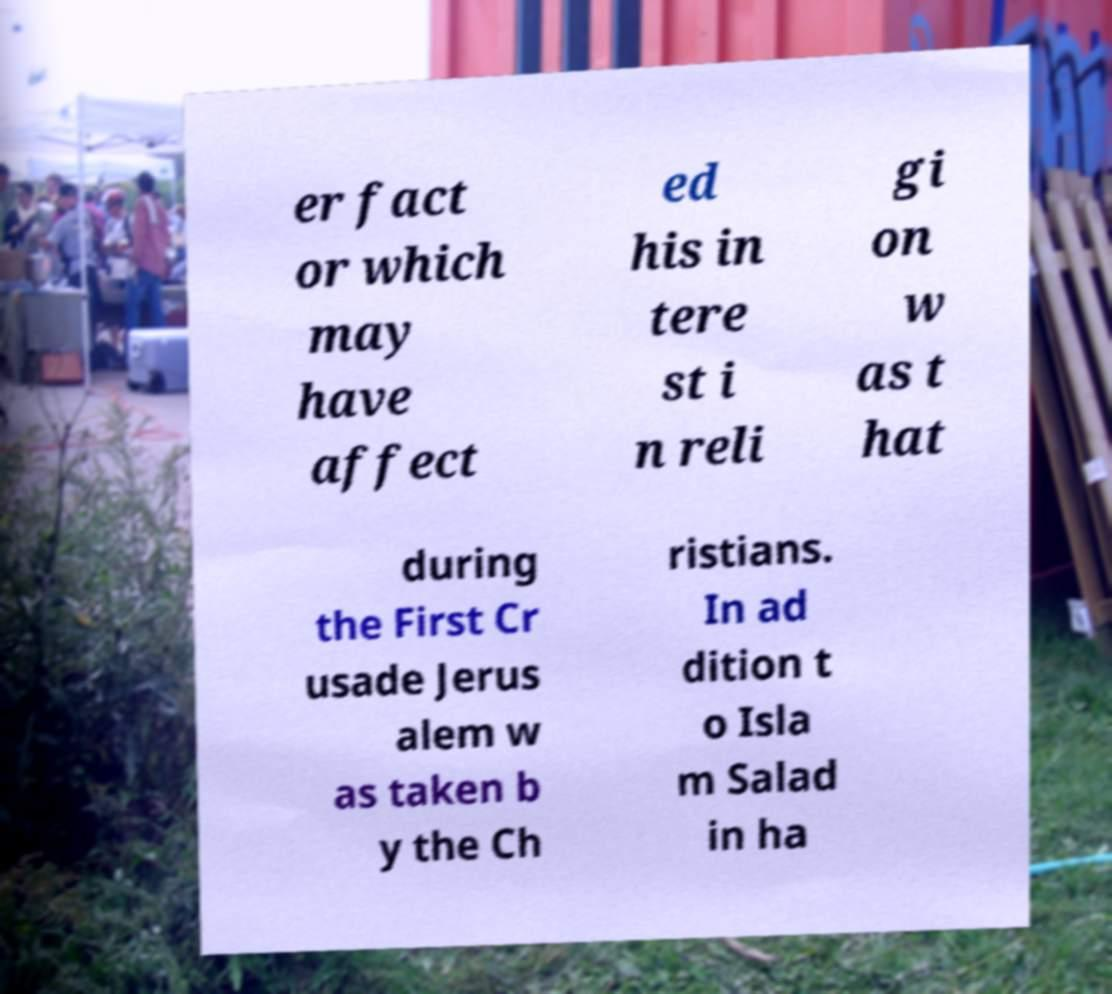Can you accurately transcribe the text from the provided image for me? er fact or which may have affect ed his in tere st i n reli gi on w as t hat during the First Cr usade Jerus alem w as taken b y the Ch ristians. In ad dition t o Isla m Salad in ha 